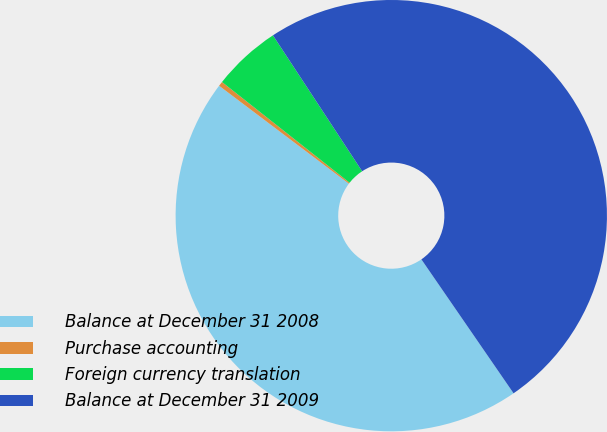Convert chart to OTSL. <chart><loc_0><loc_0><loc_500><loc_500><pie_chart><fcel>Balance at December 31 2008<fcel>Purchase accounting<fcel>Foreign currency translation<fcel>Balance at December 31 2009<nl><fcel>44.88%<fcel>0.35%<fcel>5.12%<fcel>49.65%<nl></chart> 